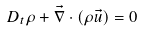<formula> <loc_0><loc_0><loc_500><loc_500>D _ { t } \rho + \vec { \nabla } \cdot \left ( \rho \vec { u } \right ) = 0</formula> 